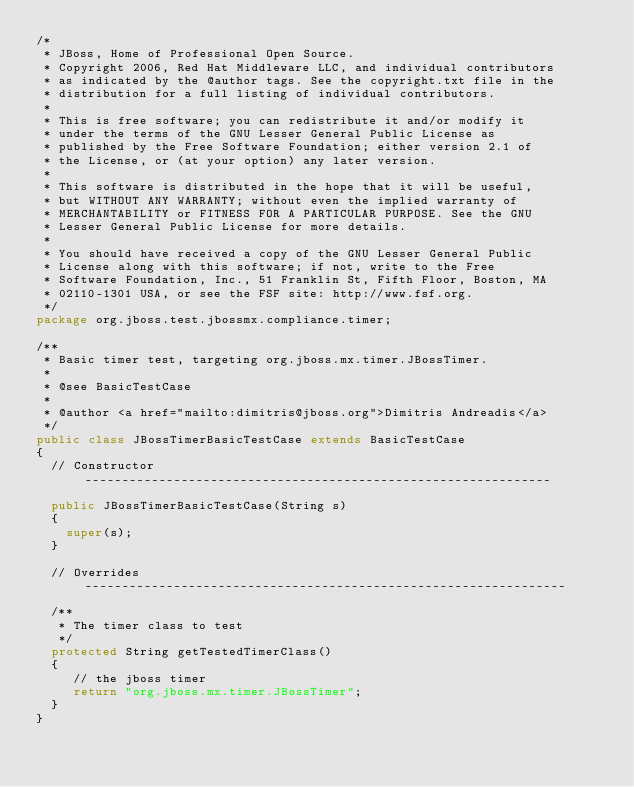<code> <loc_0><loc_0><loc_500><loc_500><_Java_>/*
 * JBoss, Home of Professional Open Source.
 * Copyright 2006, Red Hat Middleware LLC, and individual contributors
 * as indicated by the @author tags. See the copyright.txt file in the
 * distribution for a full listing of individual contributors.
 *
 * This is free software; you can redistribute it and/or modify it
 * under the terms of the GNU Lesser General Public License as
 * published by the Free Software Foundation; either version 2.1 of
 * the License, or (at your option) any later version.
 *
 * This software is distributed in the hope that it will be useful,
 * but WITHOUT ANY WARRANTY; without even the implied warranty of
 * MERCHANTABILITY or FITNESS FOR A PARTICULAR PURPOSE. See the GNU
 * Lesser General Public License for more details.
 *
 * You should have received a copy of the GNU Lesser General Public
 * License along with this software; if not, write to the Free
 * Software Foundation, Inc., 51 Franklin St, Fifth Floor, Boston, MA
 * 02110-1301 USA, or see the FSF site: http://www.fsf.org.
 */
package org.jboss.test.jbossmx.compliance.timer;

/**
 * Basic timer test, targeting org.jboss.mx.timer.JBossTimer.
 * 
 * @see BasicTestCase
 * 
 * @author <a href="mailto:dimitris@jboss.org">Dimitris Andreadis</a>
 */
public class JBossTimerBasicTestCase extends BasicTestCase
{
  // Constructor ---------------------------------------------------------------

  public JBossTimerBasicTestCase(String s)
  {
    super(s);
  }

  // Overrides -----------------------------------------------------------------
  
  /**
   * The timer class to test
   */
  protected String getTestedTimerClass()
  {
     // the jboss timer
     return "org.jboss.mx.timer.JBossTimer";
  }
}
</code> 